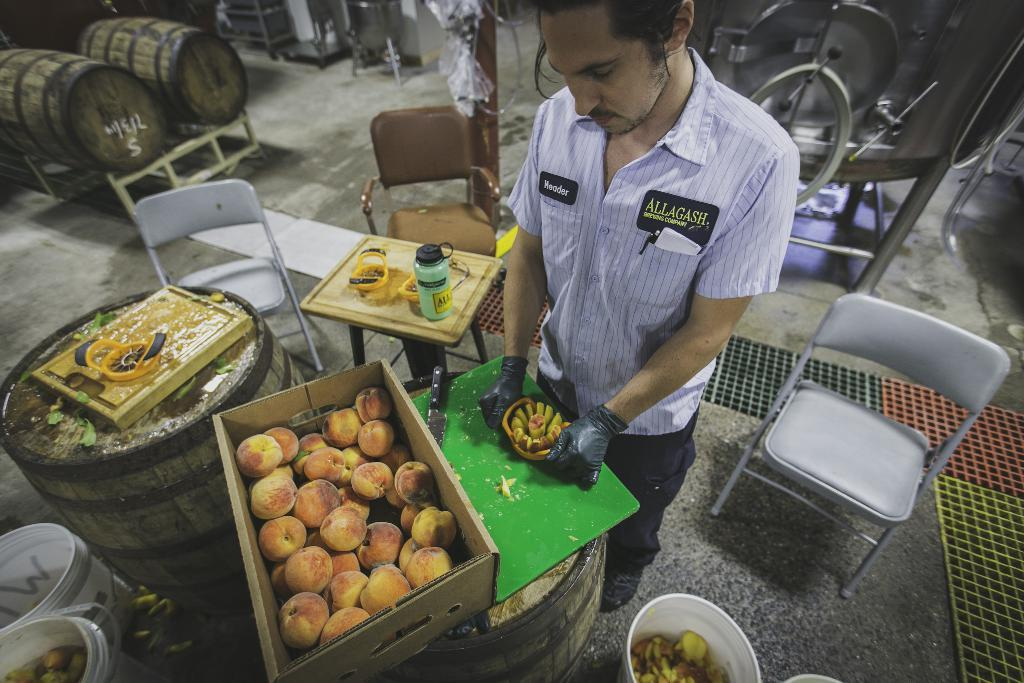What is the person in the image doing? The person is standing and holding a fruit cutter in their hands. What is the person likely to use the fruit cutter for? The person is likely to use the fruit cutter for cutting fruits, as there are baskets filled with fruits in the image. What surface is the person using to cut the fruits? There is a chopping board in the image, which the person might be using to cut the fruits. What type of seating is available in the image? There are chairs in the image. What other objects can be seen in the image? There are barrels and polythene covers in the image. What type of hill can be seen in the background of the image? There is no hill visible in the image. What type of bears are interacting with the person in the image? There are no bears present in the image. 